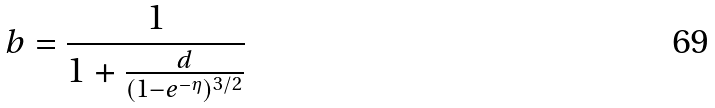<formula> <loc_0><loc_0><loc_500><loc_500>b = \frac { 1 } { 1 + \frac { d } { ( 1 - e ^ { - \eta } ) ^ { 3 / 2 } } }</formula> 